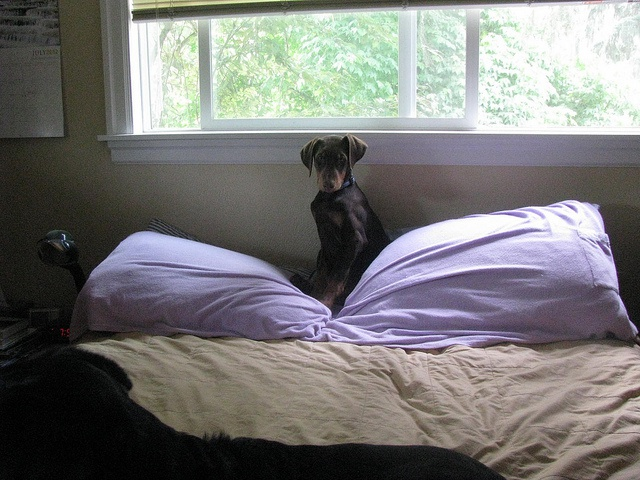Describe the objects in this image and their specific colors. I can see bed in black, gray, darkgray, and lavender tones, dog in black and gray tones, book in black tones, and clock in black, maroon, and brown tones in this image. 